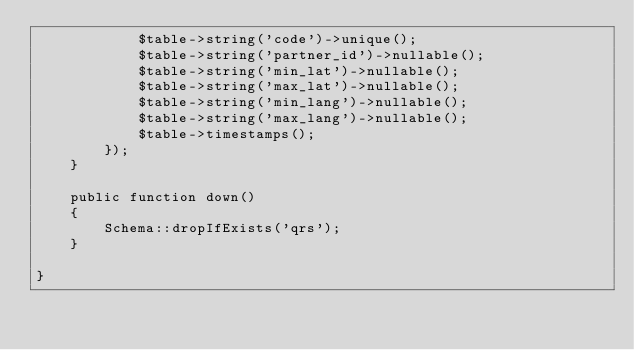<code> <loc_0><loc_0><loc_500><loc_500><_PHP_>            $table->string('code')->unique();
            $table->string('partner_id')->nullable();
            $table->string('min_lat')->nullable();
            $table->string('max_lat')->nullable();
            $table->string('min_lang')->nullable();
            $table->string('max_lang')->nullable();
            $table->timestamps();
        });
    }

    public function down()
    {
        Schema::dropIfExists('qrs');
    }

}
</code> 